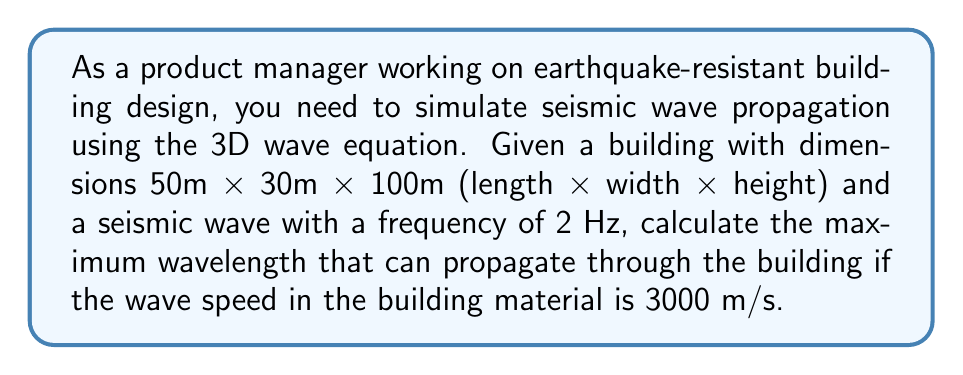Provide a solution to this math problem. To solve this problem, we'll follow these steps:

1. Recall the relationship between wave speed, frequency, and wavelength:
   $$v = f\lambda$$
   where $v$ is wave speed, $f$ is frequency, and $\lambda$ is wavelength.

2. We are given:
   - Wave speed: $v = 3000$ m/s
   - Frequency: $f = 2$ Hz

3. Rearrange the equation to solve for wavelength:
   $$\lambda = \frac{v}{f}$$

4. Substitute the known values:
   $$\lambda = \frac{3000\text{ m/s}}{2\text{ Hz}} = 1500\text{ m}$$

5. Consider the building dimensions:
   - Length: 50 m
   - Width: 30 m
   - Height: 100 m

6. The maximum wavelength that can propagate through the building is limited by its largest dimension, which is the height (100 m).

7. Therefore, the maximum wavelength that can effectively propagate through the building is 100 m, even though the calculated wavelength is 1500 m.

This analysis is crucial for earthquake-resistant design, as it helps determine which frequencies and wavelengths of seismic waves will most significantly affect the building structure.
Answer: 100 m 